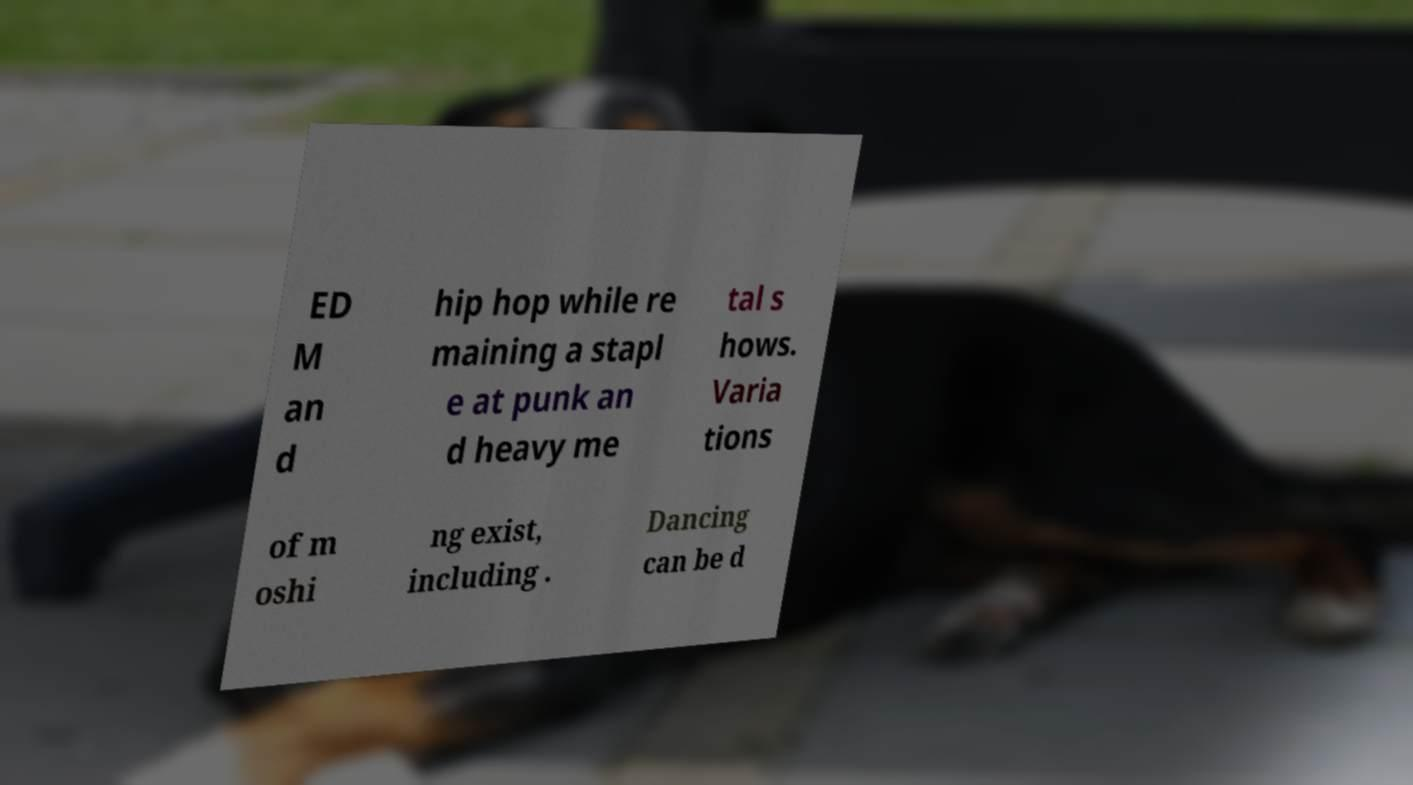Please identify and transcribe the text found in this image. ED M an d hip hop while re maining a stapl e at punk an d heavy me tal s hows. Varia tions of m oshi ng exist, including . Dancing can be d 